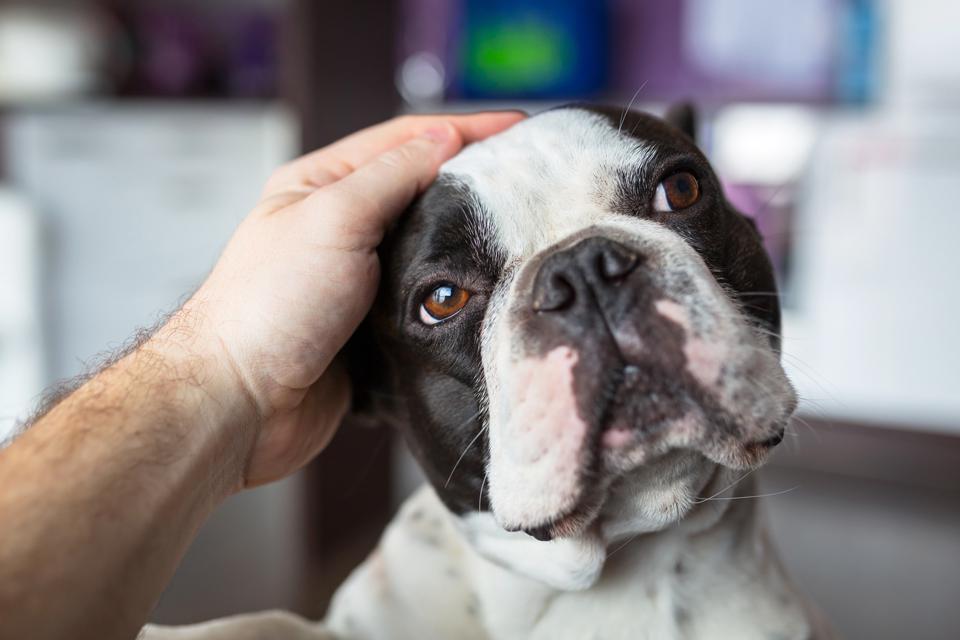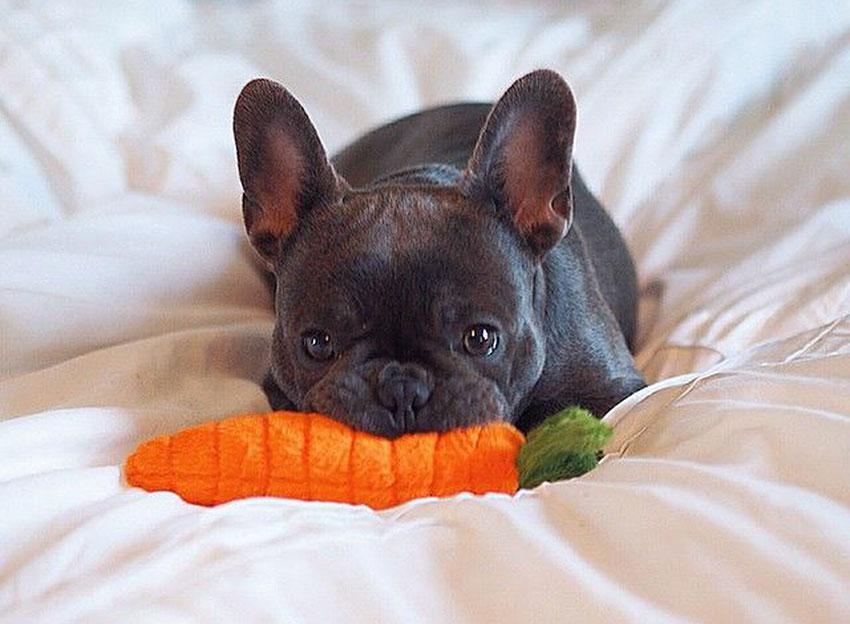The first image is the image on the left, the second image is the image on the right. Given the left and right images, does the statement "The dog in the left image is being touched by a human hand." hold true? Answer yes or no. Yes. The first image is the image on the left, the second image is the image on the right. Analyze the images presented: Is the assertion "A dog's ears are covered by articles of clothing." valid? Answer yes or no. No. 